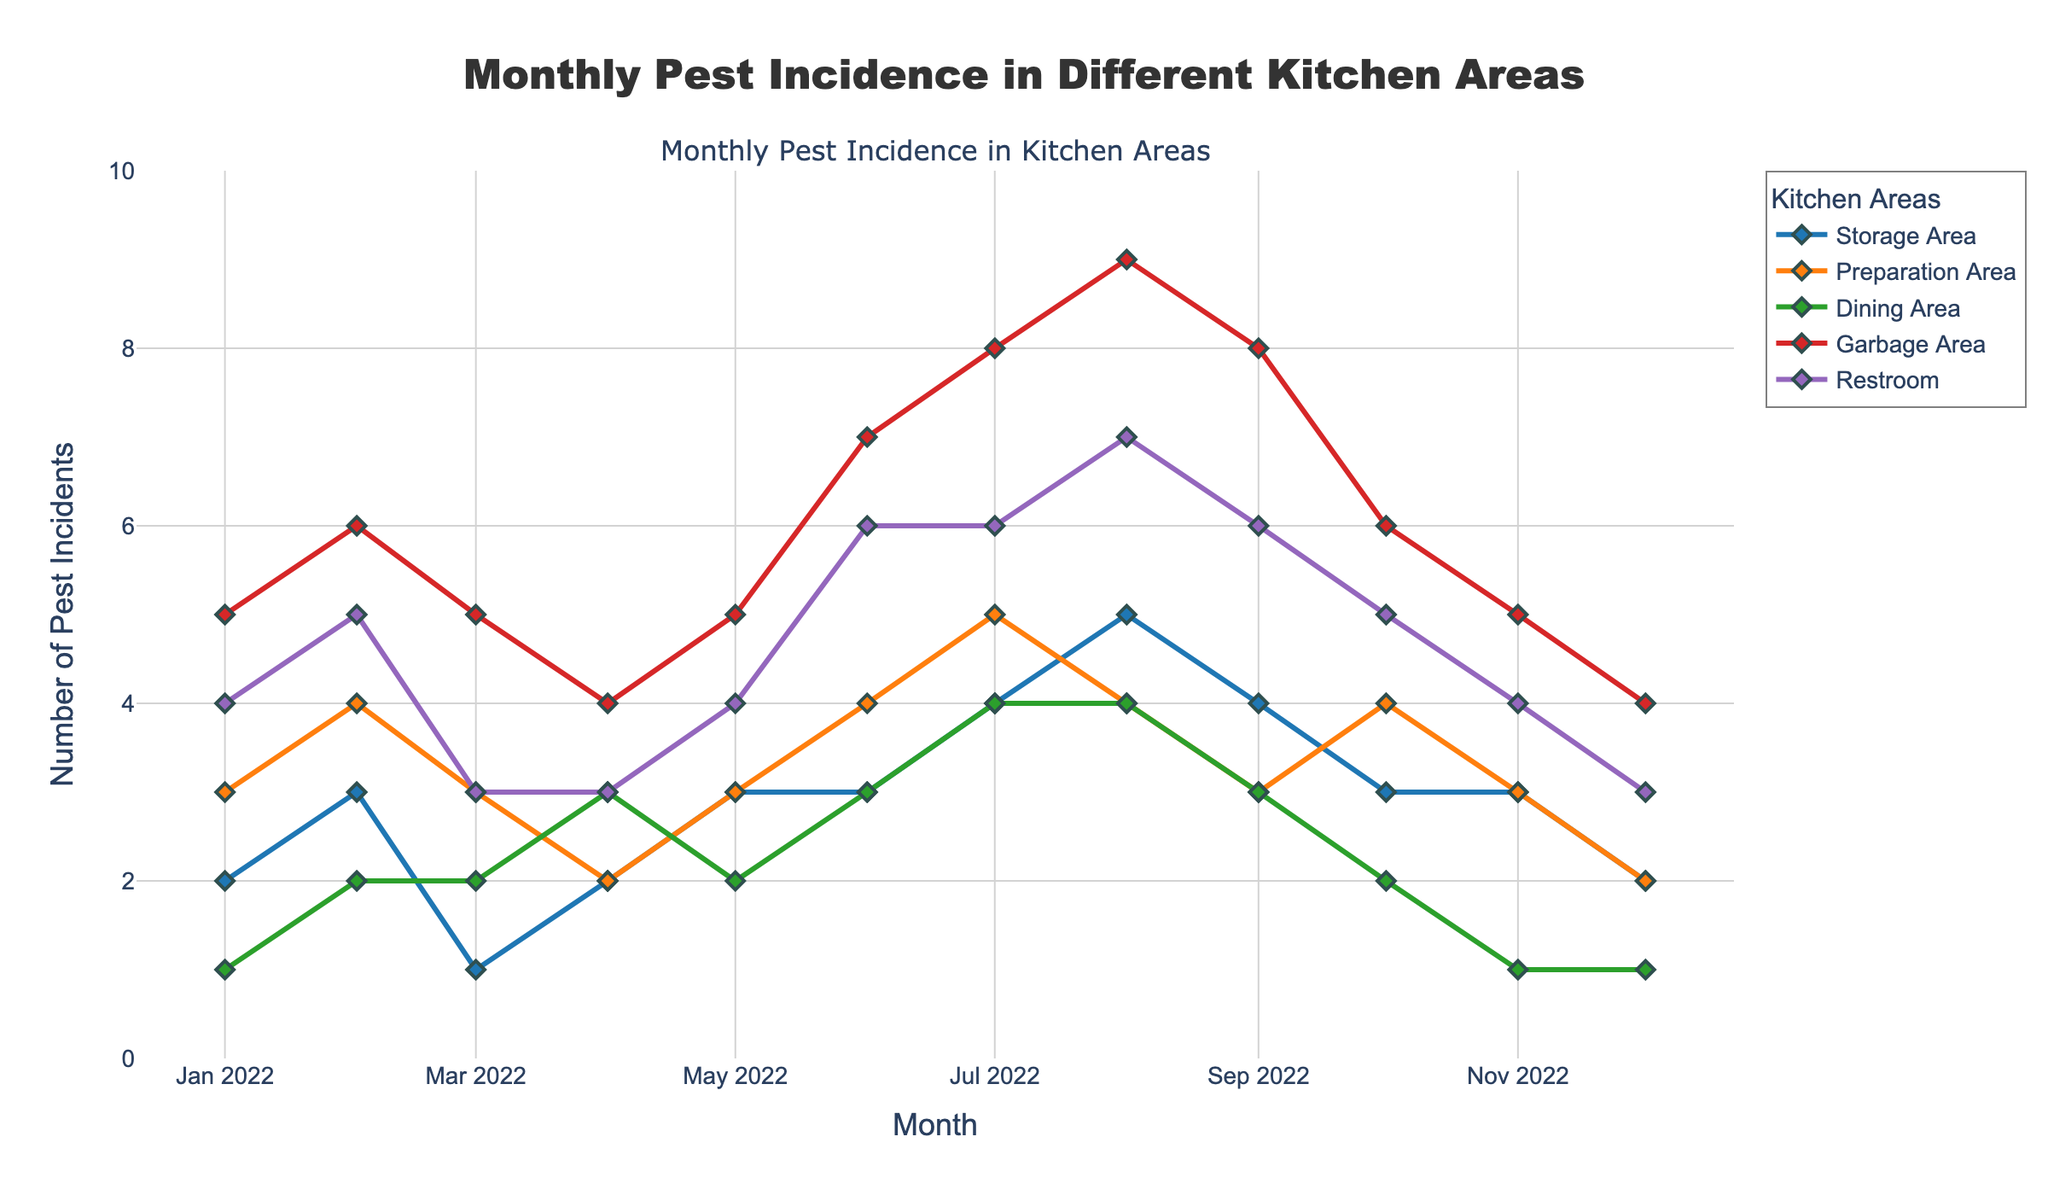What is the title of the figure? The title is clearly written at the top of the plot.
Answer: Monthly Pest Incidence in Different Kitchen Areas What was the highest number of pest incidents in any area in 2022? Look for the highest data point among all the areas in the plot. The Garbage Area reached 9 incidents in August.
Answer: 9 Which month had the fewest pest incidents in the Restroom? Observe the Restroom plot line; the lowest point is in March and December with 3 incidents.
Answer: March and December Which area had the most pest incidents in July? Check the plot lines for July; the Garbage Area peaked at 8 incidents.
Answer: Garbage Area What are the pest incident trends in the Garbage Area from January to December? The Garbage Area starts at 5 incidents in January, peaks at 9 in August, and ends the year with 4 incidents, showing a mostly increasing trend until it peaks and then a slight decrease.
Answer: Increasing till August then decreasing How do the pest incidents in the Preparation Area compare between April and October? Look at the Preparation Area line. Both April and October have 4 incidents.
Answer: Equal What's the average number of pest incidents in the Storage Area over the entire year? Sum all the values in the Storage Area and divide by the number of months (12). (2 + 3 + 1 + 2 + 3 + 3 + 4 + 5 + 4 + 3 + 3 + 2) / 12 = 3
Answer: 3 Identify the month with the largest number of pest incidents in the Dining Area. Identify the highest point in the Dining Area line, which is in July and August with 4 incidents each.
Answer: July and August Compare the trends of pest incidents in the Dining Area and Preparation Area throughout the year. Both areas show a similar trend with incidents peaking in mid-summer and lower incidents at the start and end of the year. However, the Preparation Area has slightly more incidents on average.
Answer: Similar trends with Preparation Area higher 